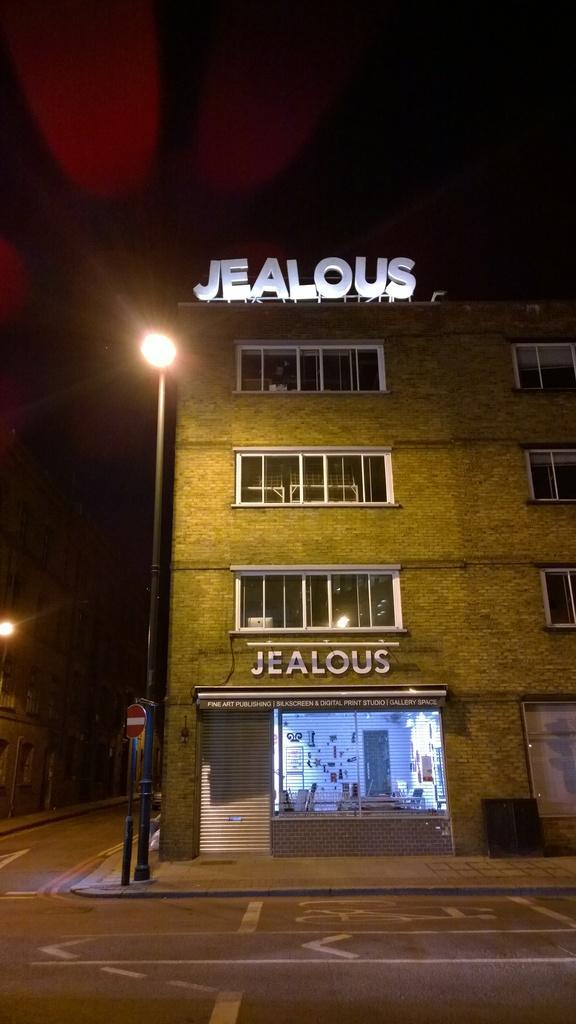In one or two sentences, can you explain what this image depicts? In the middle of the image there is a pole and sign board and building. 